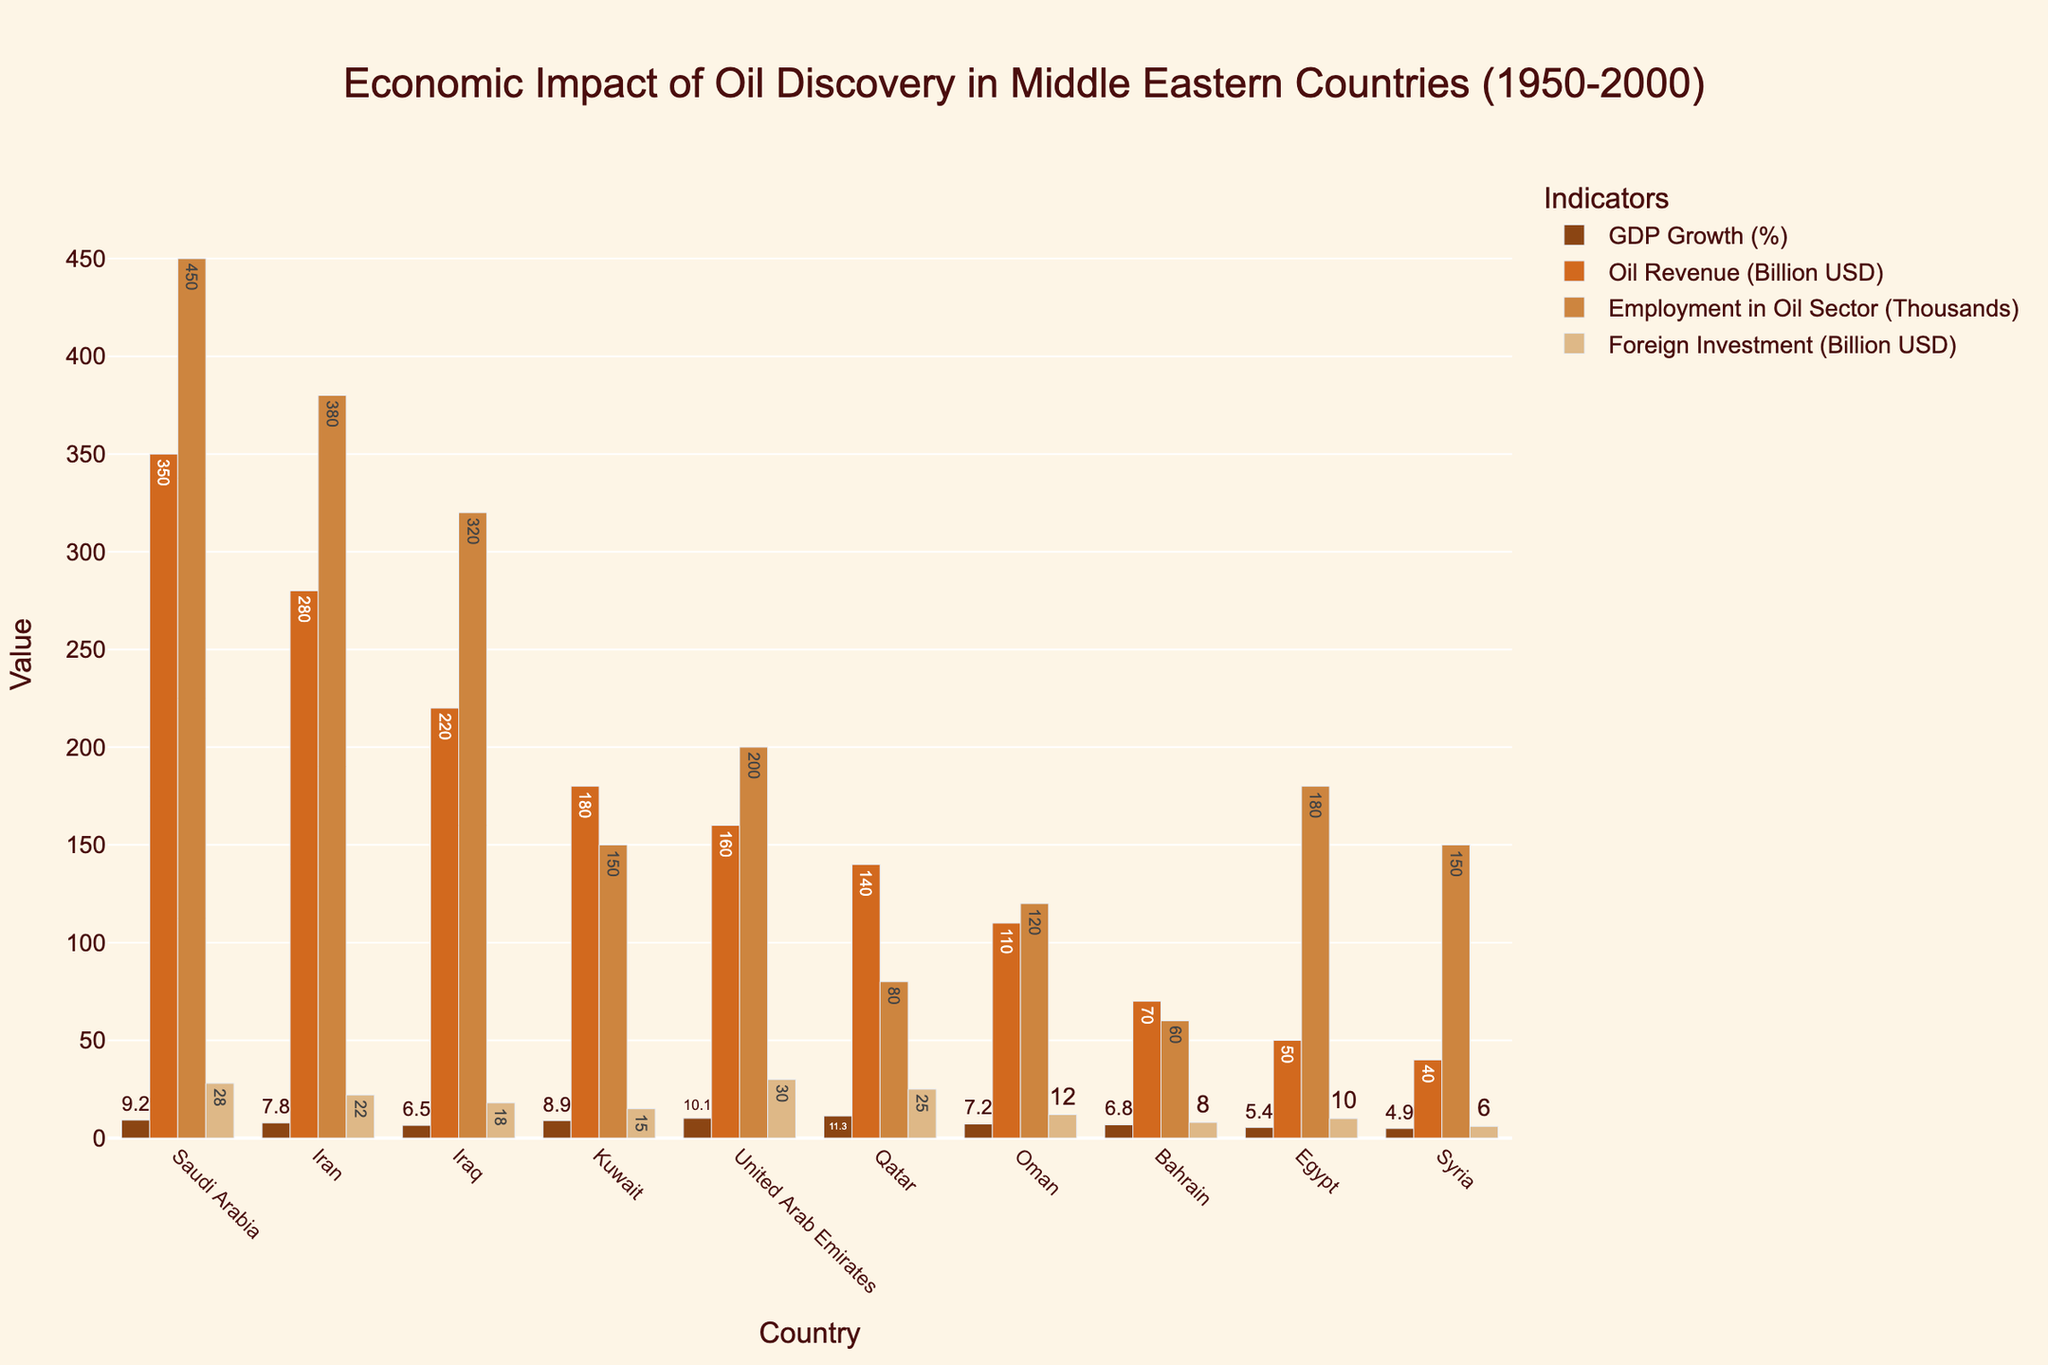Which country has the highest GDP Growth (%)? The bar for GDP Growth (%) has the tallest height for Qatar, indicating it has the highest value.
Answer: Qatar Which country shows the greatest amount of Foreign Investment (Billion USD)? The bar for Foreign Investment (Billion USD) is the highest for UAE, indicating it has the largest value.
Answer: UAE Compare the Oil Revenue (Billion USD) between Saudi Arabia and Iran. Which country has the higher value? The bar for Oil Revenue (Billion USD) is higher for Saudi Arabia compared to Iran, showing Saudi Arabia has more oil revenue.
Answer: Saudi Arabia Which country has the least Employment in the Oil Sector (Thousands)? The length of the Employment in Oil Sector (Thousands) bar is the shortest for Bahrain, indicating the lowest employment in the sector.
Answer: Bahrain What is the difference in Oil Revenue (Billion USD) between Kuwait and Iraq? The Oil Revenue (Billion USD) for Iraq is 220 and for Kuwait is 180. The difference is 220 - 180.
Answer: 40 Which two countries have the closest GDP Growth (%)? Bahrain and Egypt have GDP Growth (%) bars that are almost of equal height, making their values closest to each other.
Answer: Bahrain and Egypt What is the average GDP Growth (%) across all countries? Sum all the GDP Growth (%) values: 9.2 + 7.8 + 6.5 + 8.9 + 10.1 + 11.3 + 7.2 + 6.8 + 5.4 + 4.9 = 78.1. Divide by the number of countries (10). 78.1 / 10
Answer: 7.81 Which country has more Employment in the Oil Sector, Qatar or Oman? The bar for Employment in the Oil Sector (Thousands) is higher for Oman compared to Qatar.
Answer: Oman How does the amount of Foreign Investment (Billion USD) in Bahrain compare to Syria? The bar for Foreign Investment (Billion USD) is higher for Bahrain than Syria, indicating that Bahrain has more foreign investment.
Answer: Bahrain Rank the countries by their Oil Revenue (Billion USD) from highest to lowest. Order the countries from the highest to lowest bar: Saudi Arabia, Iran, Iraq, Kuwait, UAE, Qatar, Oman, Bahrain, Egypt, Syria.
Answer: Saudi Arabia, Iran, Iraq, Kuwait, UAE, Qatar, Oman, Bahrain, Egypt, Syria 